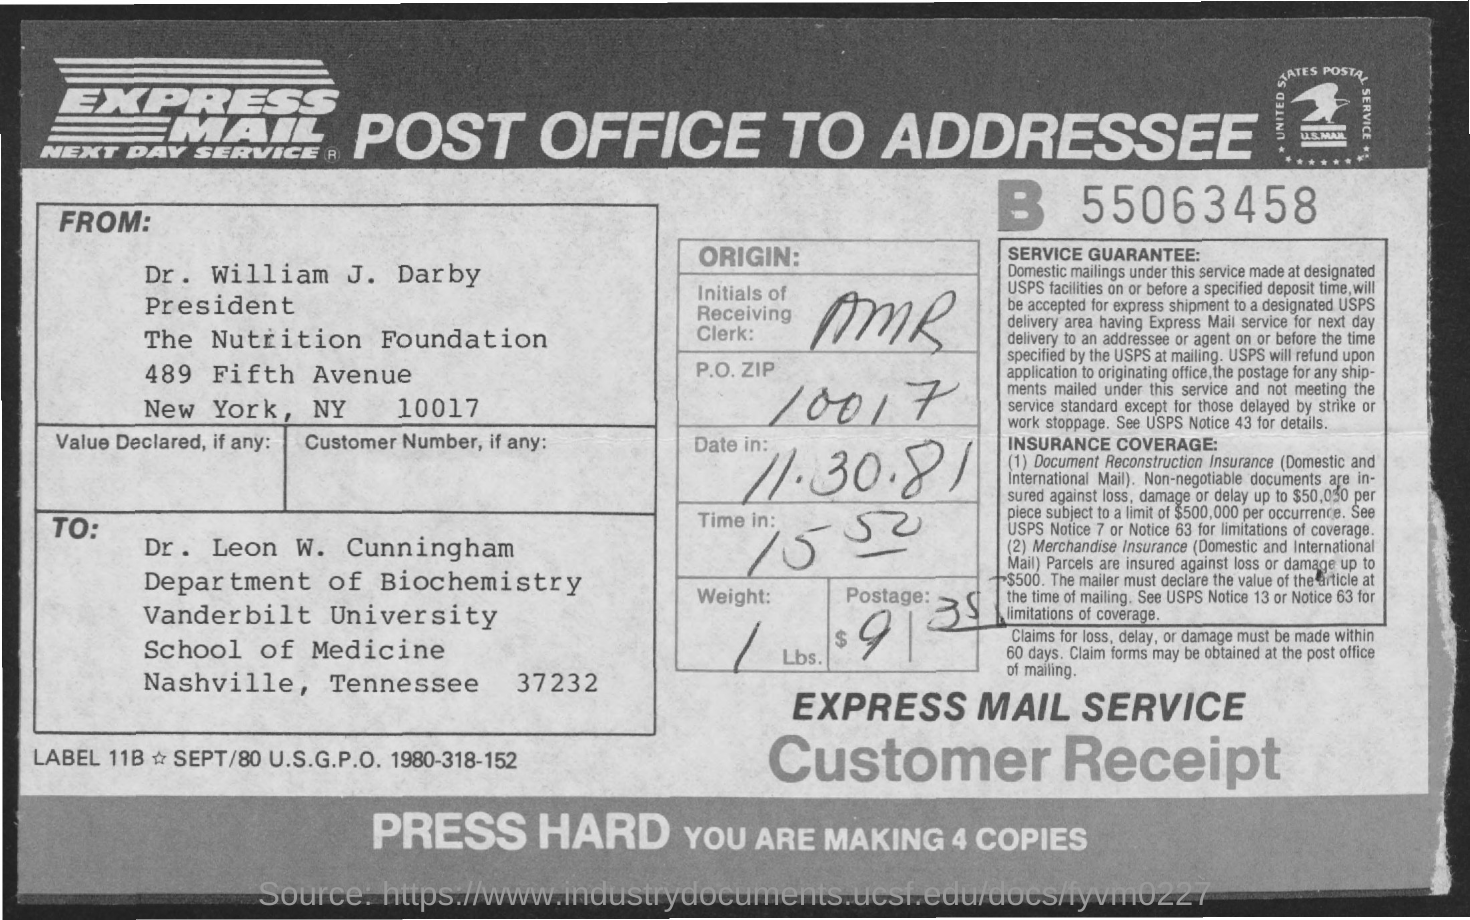What is the P.O. Zip?
Offer a very short reply. 10017. What is the Date?
Keep it short and to the point. 11.30.81. What is the Time In?
Provide a succinct answer. 15.50. What is the weight?
Give a very brief answer. 1 lbs. What is the Postage?
Your answer should be very brief. $9-35. What is the Initials of the Receiving clerk?
Give a very brief answer. AMR. 